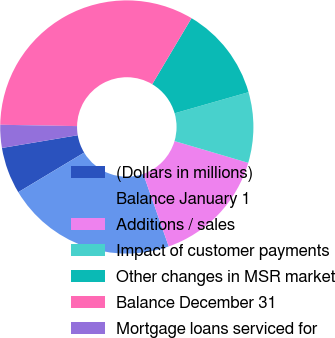Convert chart. <chart><loc_0><loc_0><loc_500><loc_500><pie_chart><fcel>(Dollars in millions)<fcel>Balance January 1<fcel>Additions / sales<fcel>Impact of customer payments<fcel>Other changes in MSR market<fcel>Balance December 31<fcel>Mortgage loans serviced for<nl><fcel>5.96%<fcel>21.76%<fcel>15.06%<fcel>9.0%<fcel>12.03%<fcel>33.26%<fcel>2.93%<nl></chart> 